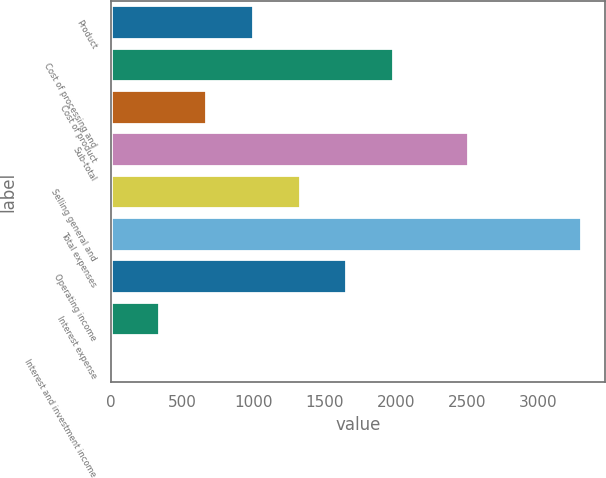Convert chart. <chart><loc_0><loc_0><loc_500><loc_500><bar_chart><fcel>Product<fcel>Cost of processing and<fcel>Cost of product<fcel>Sub-total<fcel>Selling general and<fcel>Total expenses<fcel>Operating income<fcel>Interest expense<fcel>Interest and investment income<nl><fcel>993.9<fcel>1981.8<fcel>664.6<fcel>2504<fcel>1323.2<fcel>3299<fcel>1652.5<fcel>335.3<fcel>6<nl></chart> 